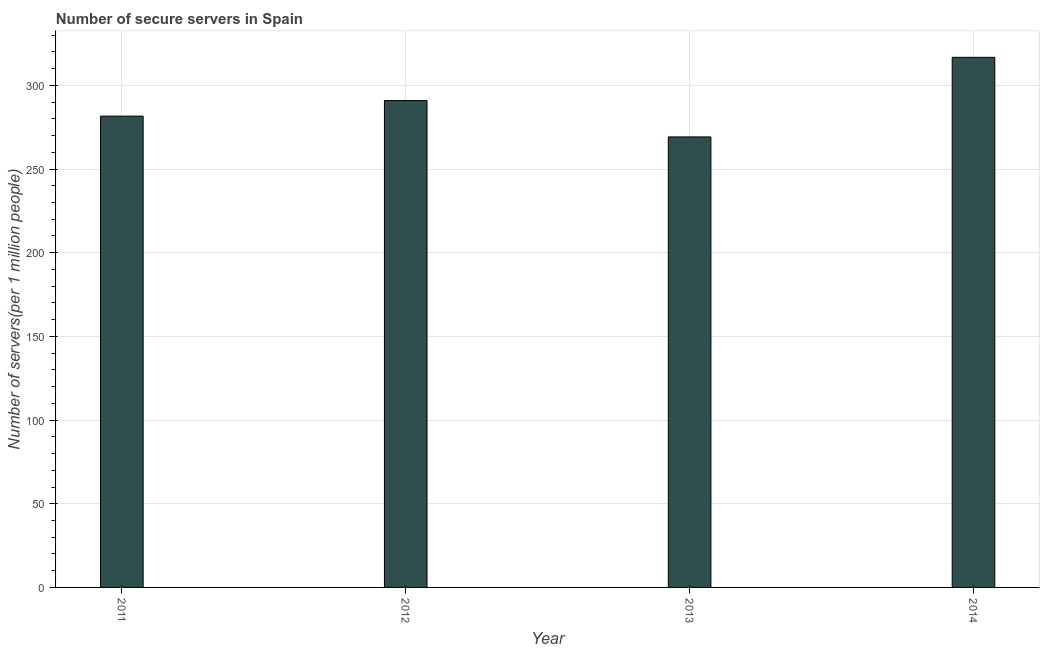Does the graph contain grids?
Provide a succinct answer. Yes. What is the title of the graph?
Your answer should be very brief. Number of secure servers in Spain. What is the label or title of the X-axis?
Your answer should be very brief. Year. What is the label or title of the Y-axis?
Provide a succinct answer. Number of servers(per 1 million people). What is the number of secure internet servers in 2014?
Keep it short and to the point. 316.76. Across all years, what is the maximum number of secure internet servers?
Keep it short and to the point. 316.76. Across all years, what is the minimum number of secure internet servers?
Provide a succinct answer. 269.2. In which year was the number of secure internet servers maximum?
Give a very brief answer. 2014. In which year was the number of secure internet servers minimum?
Your answer should be compact. 2013. What is the sum of the number of secure internet servers?
Make the answer very short. 1158.5. What is the difference between the number of secure internet servers in 2011 and 2012?
Provide a short and direct response. -9.29. What is the average number of secure internet servers per year?
Your response must be concise. 289.62. What is the median number of secure internet servers?
Give a very brief answer. 286.27. In how many years, is the number of secure internet servers greater than 260 ?
Your response must be concise. 4. What is the ratio of the number of secure internet servers in 2012 to that in 2014?
Offer a terse response. 0.92. Is the difference between the number of secure internet servers in 2011 and 2014 greater than the difference between any two years?
Your answer should be very brief. No. What is the difference between the highest and the second highest number of secure internet servers?
Make the answer very short. 25.84. What is the difference between the highest and the lowest number of secure internet servers?
Offer a terse response. 47.56. Are all the bars in the graph horizontal?
Keep it short and to the point. No. How many years are there in the graph?
Ensure brevity in your answer.  4. What is the difference between two consecutive major ticks on the Y-axis?
Your response must be concise. 50. Are the values on the major ticks of Y-axis written in scientific E-notation?
Keep it short and to the point. No. What is the Number of servers(per 1 million people) in 2011?
Offer a very short reply. 281.63. What is the Number of servers(per 1 million people) in 2012?
Give a very brief answer. 290.92. What is the Number of servers(per 1 million people) of 2013?
Give a very brief answer. 269.2. What is the Number of servers(per 1 million people) in 2014?
Your answer should be very brief. 316.76. What is the difference between the Number of servers(per 1 million people) in 2011 and 2012?
Provide a succinct answer. -9.29. What is the difference between the Number of servers(per 1 million people) in 2011 and 2013?
Provide a succinct answer. 12.43. What is the difference between the Number of servers(per 1 million people) in 2011 and 2014?
Your response must be concise. -35.13. What is the difference between the Number of servers(per 1 million people) in 2012 and 2013?
Your answer should be very brief. 21.72. What is the difference between the Number of servers(per 1 million people) in 2012 and 2014?
Offer a very short reply. -25.84. What is the difference between the Number of servers(per 1 million people) in 2013 and 2014?
Give a very brief answer. -47.56. What is the ratio of the Number of servers(per 1 million people) in 2011 to that in 2012?
Make the answer very short. 0.97. What is the ratio of the Number of servers(per 1 million people) in 2011 to that in 2013?
Your answer should be compact. 1.05. What is the ratio of the Number of servers(per 1 million people) in 2011 to that in 2014?
Provide a succinct answer. 0.89. What is the ratio of the Number of servers(per 1 million people) in 2012 to that in 2013?
Provide a succinct answer. 1.08. What is the ratio of the Number of servers(per 1 million people) in 2012 to that in 2014?
Give a very brief answer. 0.92. What is the ratio of the Number of servers(per 1 million people) in 2013 to that in 2014?
Your response must be concise. 0.85. 